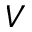Convert formula to latex. <formula><loc_0><loc_0><loc_500><loc_500>V</formula> 